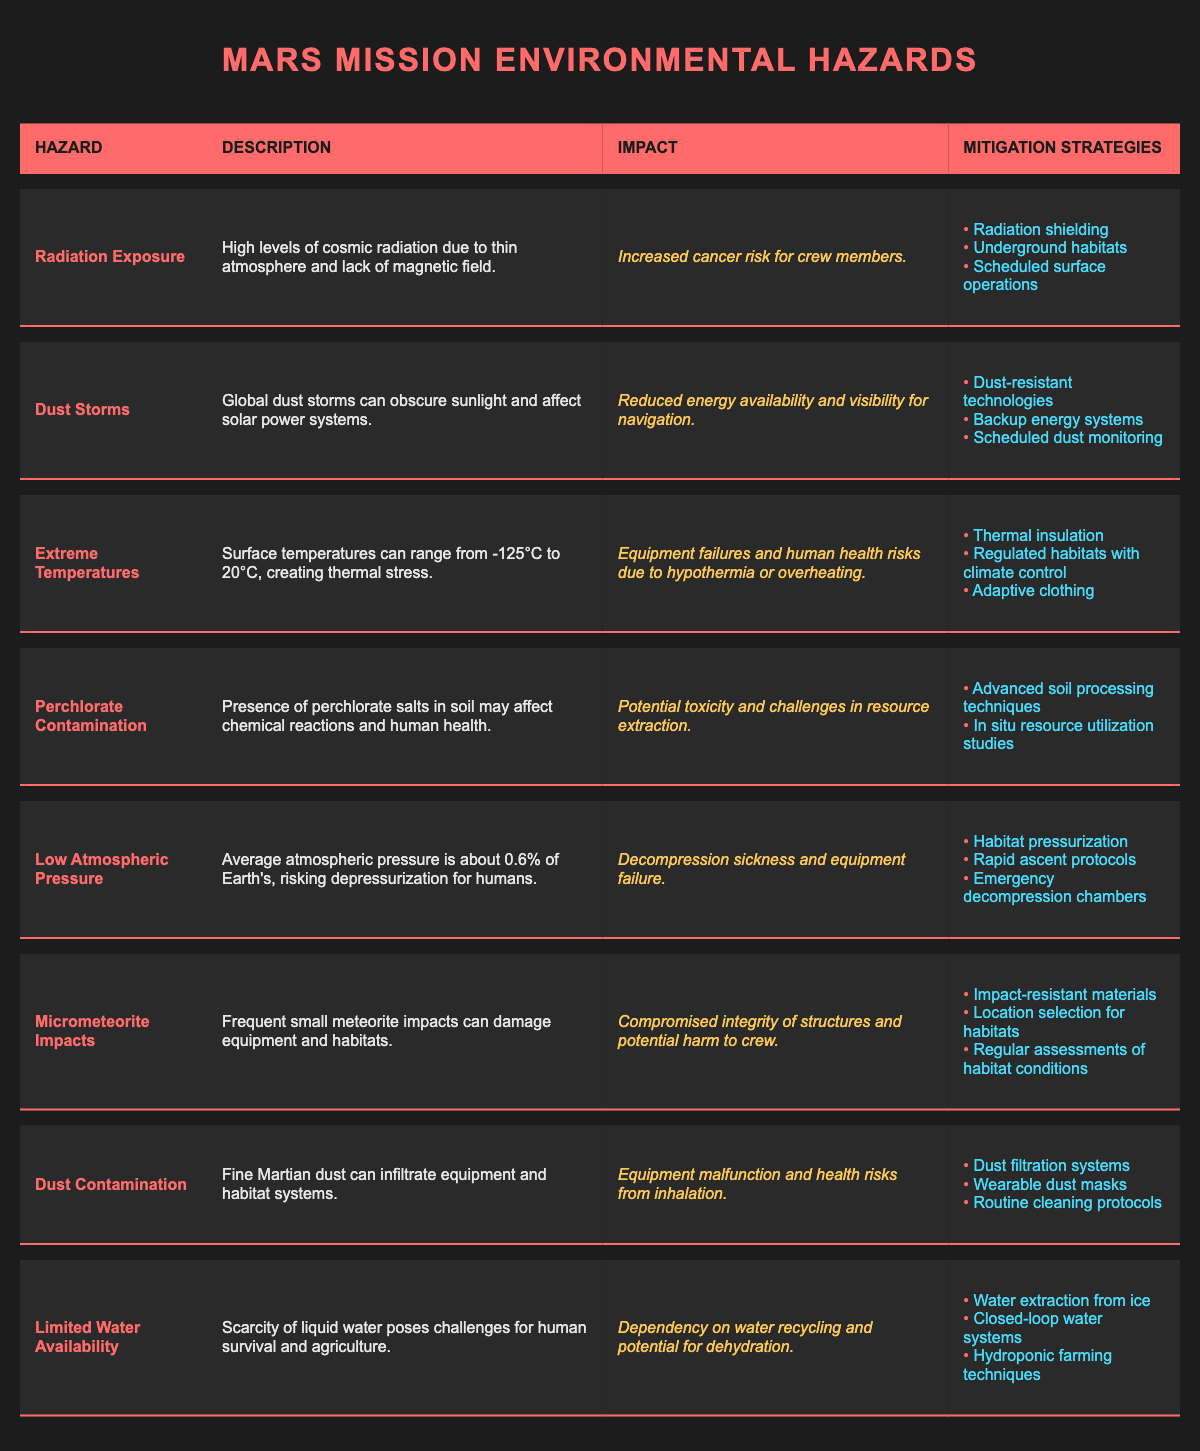What is the impact of radiation exposure? The impact of radiation exposure is listed as "Increased cancer risk for crew members." This is directly found in the description of the hazard in the table.
Answer: Increased cancer risk for crew members What are the mitigation strategies for dust storms? The mitigation strategies for dust storms include three points: "Dust-resistant technologies," "Backup energy systems," and "Scheduled dust monitoring," all of which are outlined in the dust storms row of the table.
Answer: Dust-resistant technologies, backup energy systems, scheduled dust monitoring Is extreme temperature a hazard for Mars missions? Yes, extreme temperature is listed as a hazard in the table. It has a dedicated row which discusses its significance and impact.
Answer: Yes List the impacts associated with limited water availability. The table states that the impact of limited water availability is "Dependency on water recycling and potential for dehydration." This information can be retrieved directly from the limited water availability row.
Answer: Dependency on water recycling and potential for dehydration Which hazard has the most complex mitigation strategies? Both "Micrometeorite Impacts" and "Limited Water Availability" hazards have three strategies listed, but "Limited Water Availability" has more detailed explanations on potential methods (i.e., water extraction from ice, closed-loop systems, hydroponics). This involves analysis beyond direct comparisons, but both hold equal counts.
Answer: Limited Water Availability How many total environmental hazards are listed in the table? The table lists eight different environmental hazards. This is determined by counting the number of rows in the hazards section of the table.
Answer: Eight Are underground habitats a mitigation strategy for radiation exposure? Yes, underground habitats are explicitly listed as one of the mitigation strategies under the radiation exposure hazard in the table.
Answer: Yes Which hazard can affect solar power systems? The hazard that can affect solar power systems is "Dust Storms," as described in the corresponding row. The description indicates global dust storms can obscure sunlight, thereby impacting solar energy availability.
Answer: Dust Storms 